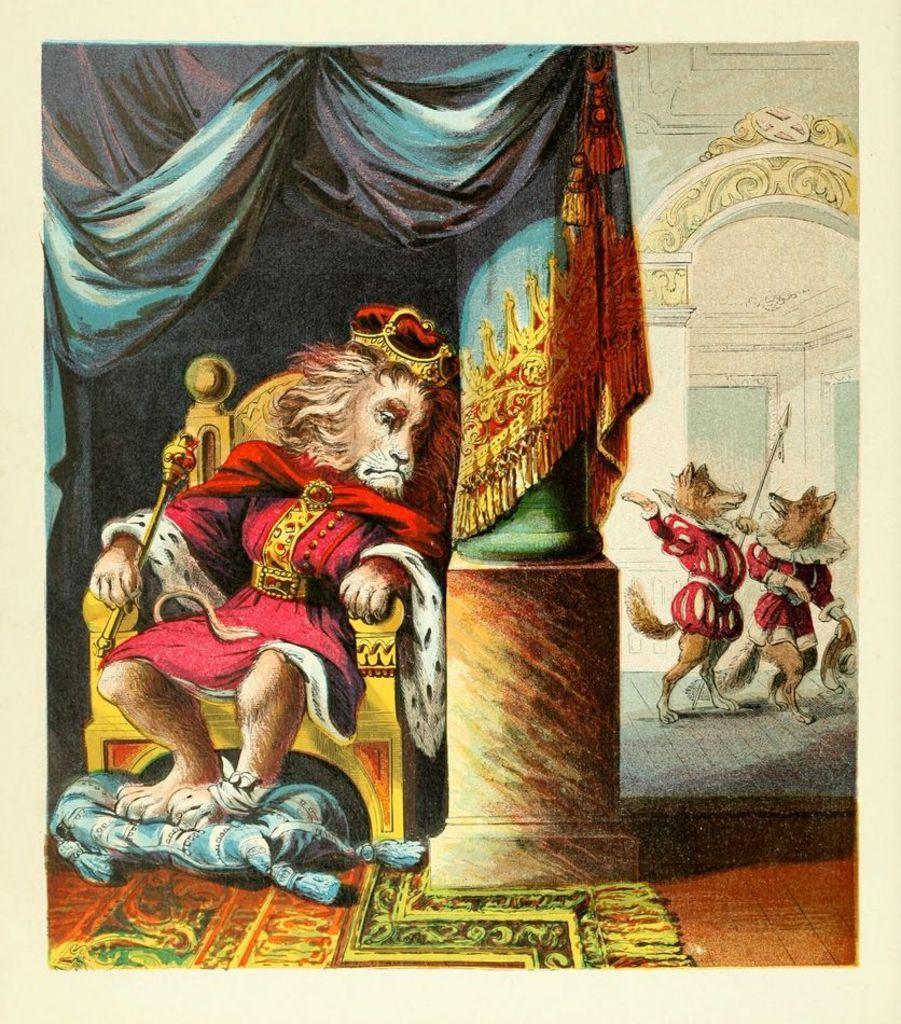How would you summarize this image in a sentence or two? This image is taken for a poster. In the right side of the image there are two foxes. At the bottom of the image there is a floor with a mat. On the right side of the image a lion is sitting on the chair and holding a stick. In the background there is a wall with a pillar and an arch and there is a cloth. 